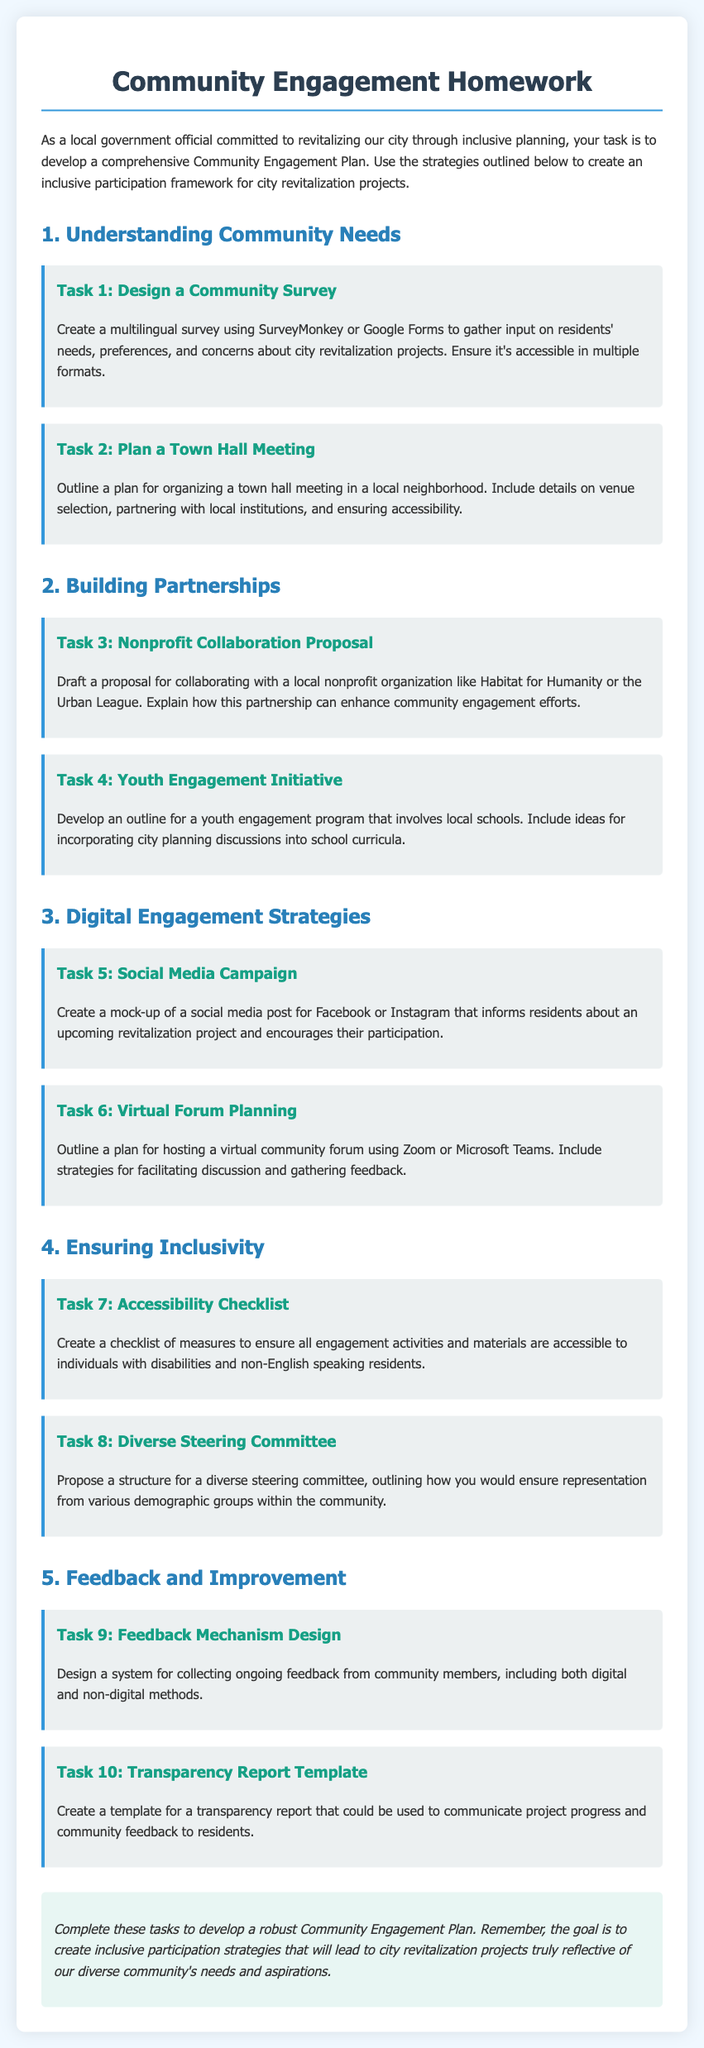What is the title of the document? The title is indicated at the top of the document.
Answer: Community Engagement Homework What is the first task in the document? The first task is specified under the section Understanding Community Needs.
Answer: Design a Community Survey Which platform is suggested for creating the survey? The document mentions platforms suitable for gathering community input.
Answer: SurveyMonkey or Google Forms What is the focus of Task 3? Task 3 outlines a collaborative effort with a specific organization to enhance community engagement.
Answer: Nonprofit Collaboration Proposal How many tasks are outlined under the section Ensuring Inclusivity? The document lists the specific number of tasks in the section on inclusivity.
Answer: Two What is required in Task 9? This task focuses on a system for gathering feedback from community members.
Answer: Feedback Mechanism Design What demographic representation is proposed in Task 8? Task 8 focuses on ensuring a variety of specific community demographics are represented.
Answer: Diverse steering committee What should the transparency report communicate? The transparency report should provide specific updates to the community regarding projects.
Answer: Project progress and community feedback 